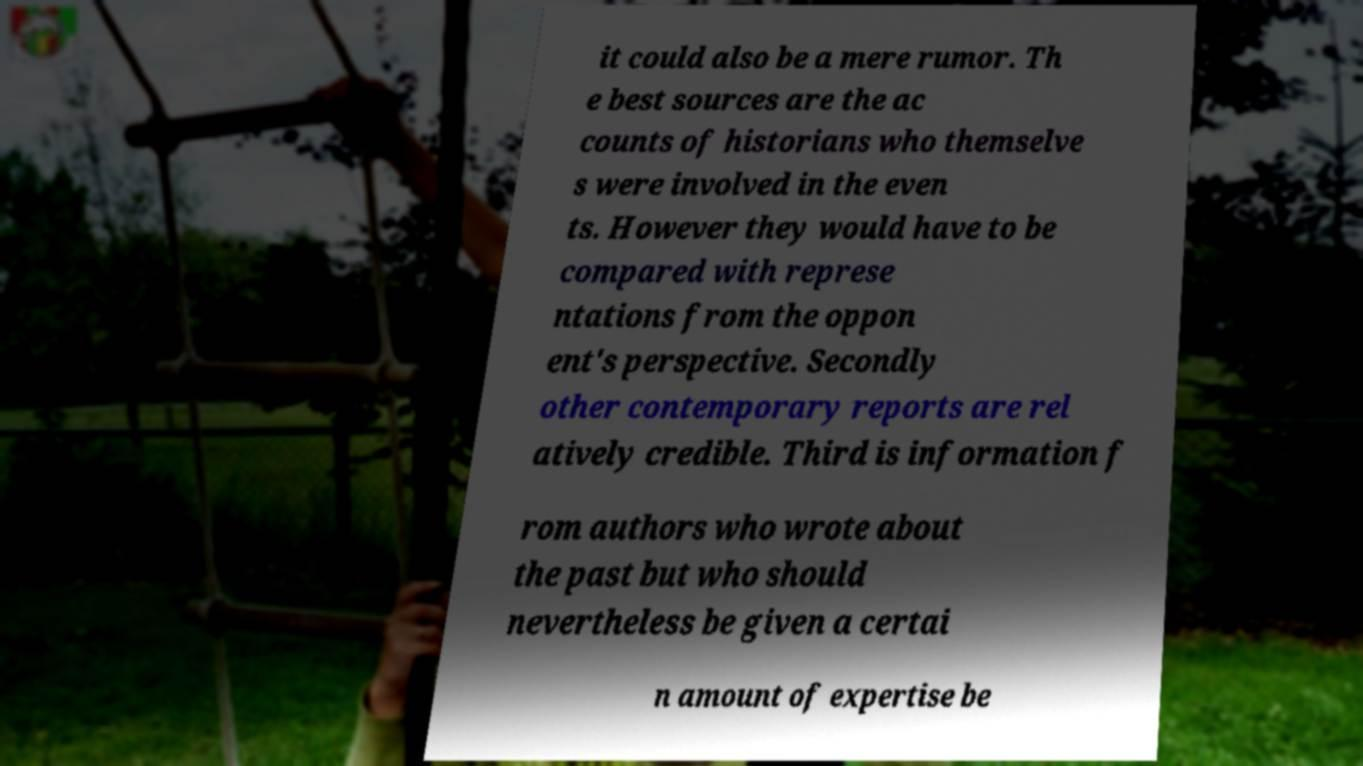For documentation purposes, I need the text within this image transcribed. Could you provide that? it could also be a mere rumor. Th e best sources are the ac counts of historians who themselve s were involved in the even ts. However they would have to be compared with represe ntations from the oppon ent's perspective. Secondly other contemporary reports are rel atively credible. Third is information f rom authors who wrote about the past but who should nevertheless be given a certai n amount of expertise be 